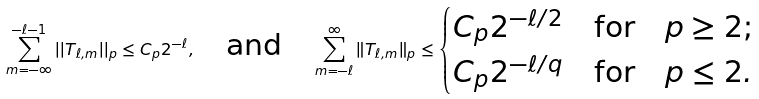<formula> <loc_0><loc_0><loc_500><loc_500>\sum ^ { - \ell - 1 } _ { m = - \infty } | | T _ { \ell , m } | | _ { p } \leq C _ { p } 2 ^ { - \ell } , \quad \text {and} \quad \sum _ { m = - \ell } ^ { \infty } \| T _ { \ell , m } \| _ { p } \leq \begin{cases} C _ { p } 2 ^ { - \ell / 2 } \quad \text {for} \quad p \geq 2 ; \\ C _ { p } 2 ^ { - \ell / q } \quad \text {for} \quad p \leq 2 . \end{cases}</formula> 